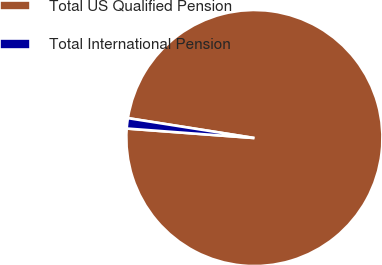Convert chart. <chart><loc_0><loc_0><loc_500><loc_500><pie_chart><fcel>Total US Qualified Pension<fcel>Total International Pension<nl><fcel>98.7%<fcel>1.3%<nl></chart> 